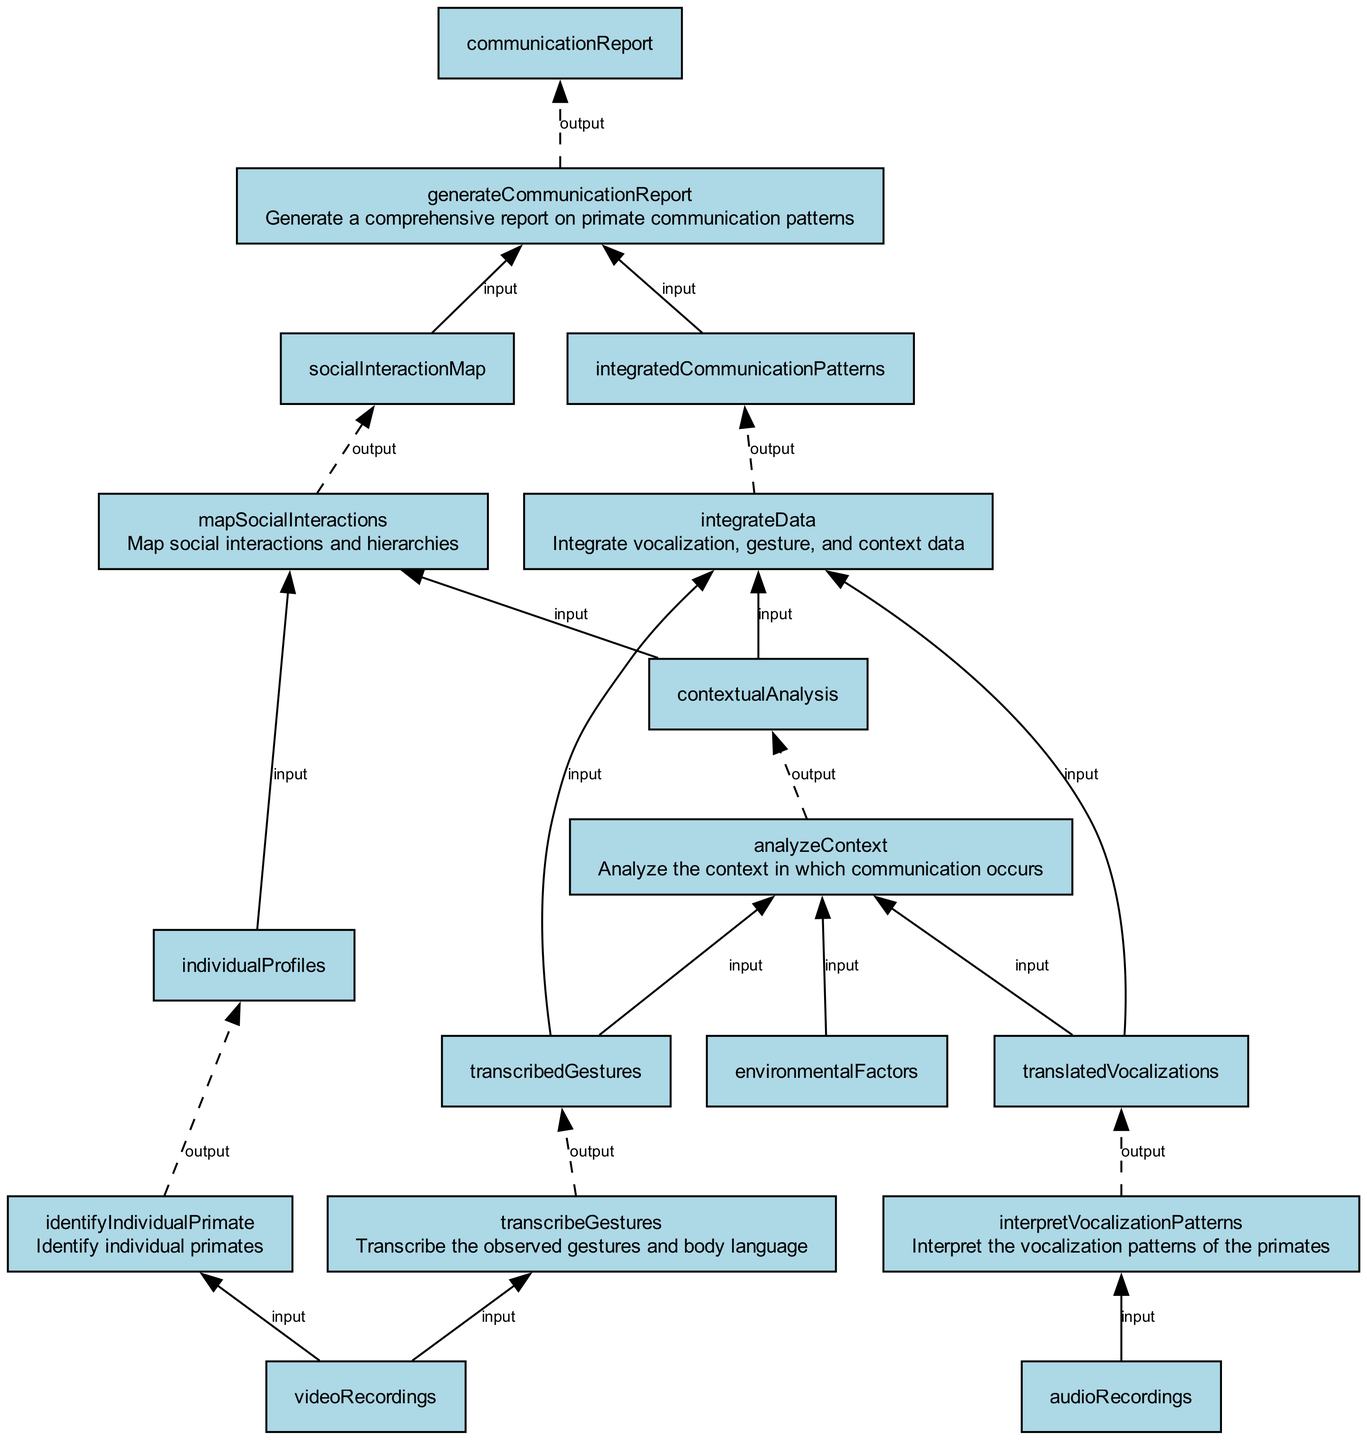What is the first step in the communication analysis process? The first step is "Interpret the vocalization patterns of the primates." This can be found at the bottom of the flowchart, which outlines the initial activity that initiates the analysis.
Answer: Interpret the vocalization patterns of the primates How many nodes are there in the diagram? The diagram consists of seven nodes representing distinct processes in the analysis workflow. Each node corresponds to a specific task.
Answer: Seven nodes What is the output of the "analyzeContext" step? The output of the "analyzeContext" step is "contextualAnalysis." This can be derived from the output listed on the node for that step, indicating what is produced after completing that step.
Answer: contextualAnalysis Which two inputs are needed for the node "mapSocialInteractions"? The inputs for "mapSocialInteractions" are "contextualAnalysis" and "individualProfiles." These are necessary to understand the dynamics based on context and individual behavior.
Answer: contextualAnalysis and individualProfiles What is the purpose of the "generateCommunicationReport" step? The purpose of the "generateCommunicationReport" step is to provide a comprehensive overview of the primate communication patterns, synthesizing the analysis results into a report.
Answer: Generate a comprehensive report on primate communication patterns What is the relationship between "integrateData" and "generateCommunicationReport"? "integrateData" feeds into "generateCommunicationReport"; the report uses the outputs and findings from "integrateData" to compile the final report on communication patterns, emphasizing their dependency in the process.
Answer: "integrateData" is input for "generateCommunicationReport" How many input elements does the "integrateData" node have? The "integrateData" node has three input elements: "translatedVocalizations," "transcribedGestures," and "contextualAnalysis," which combine to produce a single output.
Answer: Three input elements Which step combines vocalization and gesture data? The step "integrateData" combines vocalization and gesture data with additional context to analyze communication patterns in a holistic manner. This step is crucial for integrating different forms of communication studied.
Answer: integrateData 